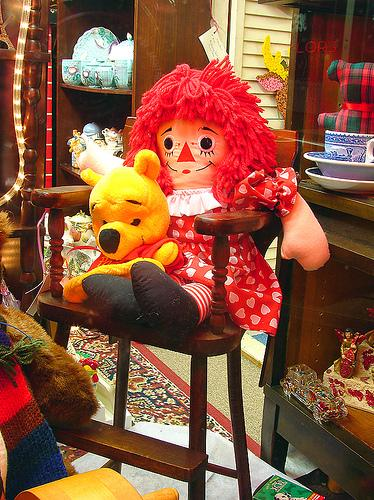What iconic child favorite is there besides Winnie the Pooh?

Choices:
A) raggedy andy
B) tigger
C) raggedy ann
D) chatty cathy raggedy ann 